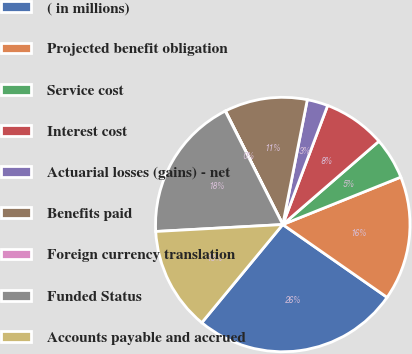Convert chart to OTSL. <chart><loc_0><loc_0><loc_500><loc_500><pie_chart><fcel>( in millions)<fcel>Projected benefit obligation<fcel>Service cost<fcel>Interest cost<fcel>Actuarial losses (gains) - net<fcel>Benefits paid<fcel>Foreign currency translation<fcel>Funded Status<fcel>Accounts payable and accrued<nl><fcel>26.28%<fcel>15.78%<fcel>5.28%<fcel>7.9%<fcel>2.65%<fcel>10.53%<fcel>0.03%<fcel>18.4%<fcel>13.15%<nl></chart> 